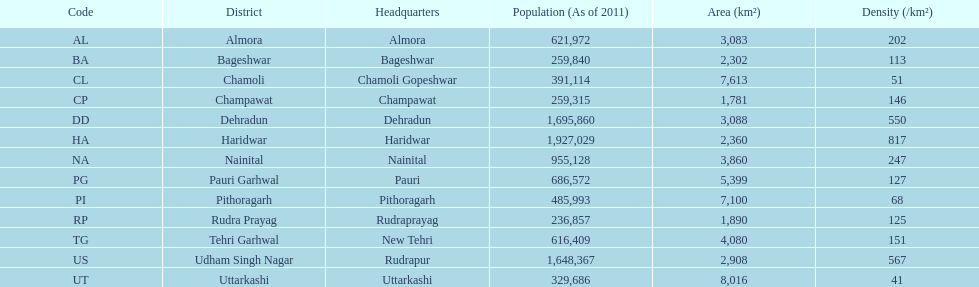In this area, how many districts can be found in total? 13. 